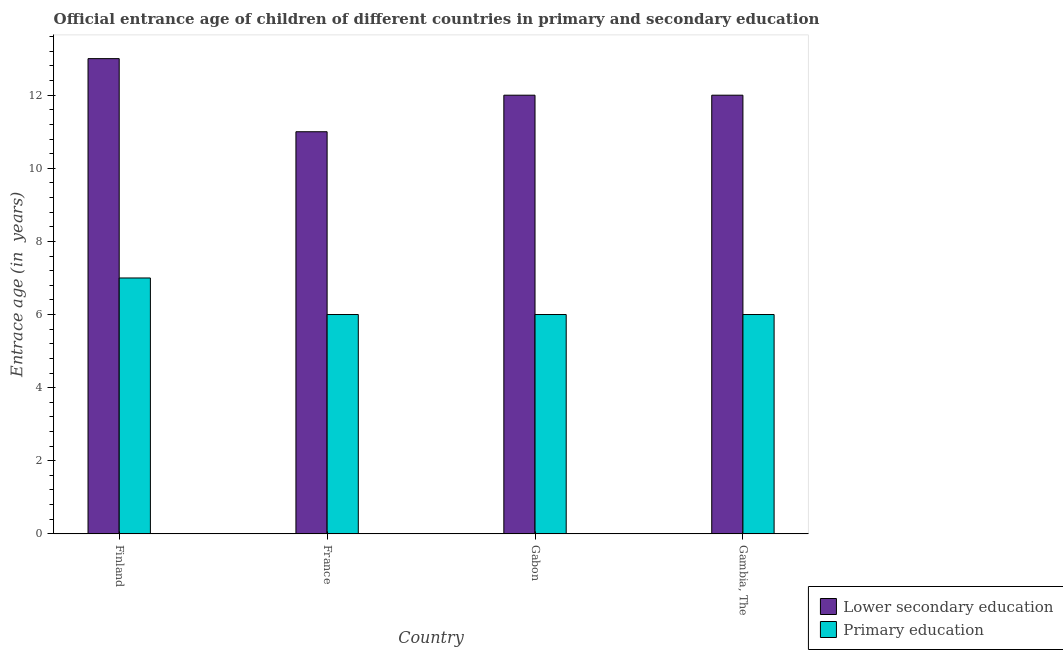Are the number of bars per tick equal to the number of legend labels?
Give a very brief answer. Yes. Are the number of bars on each tick of the X-axis equal?
Offer a very short reply. Yes. How many bars are there on the 2nd tick from the right?
Ensure brevity in your answer.  2. What is the label of the 1st group of bars from the left?
Provide a short and direct response. Finland. In how many cases, is the number of bars for a given country not equal to the number of legend labels?
Make the answer very short. 0. What is the entrance age of children in lower secondary education in Finland?
Keep it short and to the point. 13. Across all countries, what is the maximum entrance age of children in lower secondary education?
Offer a terse response. 13. Across all countries, what is the minimum entrance age of children in lower secondary education?
Keep it short and to the point. 11. In which country was the entrance age of chiildren in primary education maximum?
Ensure brevity in your answer.  Finland. In which country was the entrance age of chiildren in primary education minimum?
Provide a succinct answer. France. What is the total entrance age of children in lower secondary education in the graph?
Provide a succinct answer. 48. What is the difference between the entrance age of chiildren in primary education in Finland and that in Gambia, The?
Keep it short and to the point. 1. What is the average entrance age of chiildren in primary education per country?
Make the answer very short. 6.25. What is the difference between the entrance age of children in lower secondary education and entrance age of chiildren in primary education in Gambia, The?
Keep it short and to the point. 6. What is the ratio of the entrance age of chiildren in primary education in Gabon to that in Gambia, The?
Your answer should be very brief. 1. Is the difference between the entrance age of children in lower secondary education in France and Gabon greater than the difference between the entrance age of chiildren in primary education in France and Gabon?
Ensure brevity in your answer.  No. What is the difference between the highest and the second highest entrance age of chiildren in primary education?
Keep it short and to the point. 1. What is the difference between the highest and the lowest entrance age of chiildren in primary education?
Your answer should be compact. 1. In how many countries, is the entrance age of chiildren in primary education greater than the average entrance age of chiildren in primary education taken over all countries?
Your response must be concise. 1. What does the 2nd bar from the right in France represents?
Provide a short and direct response. Lower secondary education. How many bars are there?
Offer a terse response. 8. Are all the bars in the graph horizontal?
Offer a terse response. No. How many countries are there in the graph?
Your answer should be compact. 4. What is the difference between two consecutive major ticks on the Y-axis?
Ensure brevity in your answer.  2. Does the graph contain any zero values?
Keep it short and to the point. No. Where does the legend appear in the graph?
Keep it short and to the point. Bottom right. How are the legend labels stacked?
Make the answer very short. Vertical. What is the title of the graph?
Your response must be concise. Official entrance age of children of different countries in primary and secondary education. What is the label or title of the Y-axis?
Ensure brevity in your answer.  Entrace age (in  years). What is the Entrace age (in  years) in Lower secondary education in France?
Ensure brevity in your answer.  11. What is the Entrace age (in  years) in Primary education in France?
Ensure brevity in your answer.  6. What is the Entrace age (in  years) of Primary education in Gambia, The?
Offer a terse response. 6. What is the total Entrace age (in  years) in Lower secondary education in the graph?
Provide a succinct answer. 48. What is the difference between the Entrace age (in  years) of Lower secondary education in Finland and that in France?
Give a very brief answer. 2. What is the difference between the Entrace age (in  years) of Primary education in Finland and that in France?
Provide a short and direct response. 1. What is the difference between the Entrace age (in  years) of Lower secondary education in Finland and that in Gabon?
Give a very brief answer. 1. What is the difference between the Entrace age (in  years) of Primary education in Finland and that in Gabon?
Your response must be concise. 1. What is the difference between the Entrace age (in  years) in Lower secondary education in Finland and that in Gambia, The?
Your answer should be compact. 1. What is the difference between the Entrace age (in  years) in Primary education in Finland and that in Gambia, The?
Your answer should be very brief. 1. What is the difference between the Entrace age (in  years) in Lower secondary education in France and that in Gabon?
Keep it short and to the point. -1. What is the difference between the Entrace age (in  years) of Primary education in France and that in Gabon?
Your answer should be very brief. 0. What is the difference between the Entrace age (in  years) in Lower secondary education in France and that in Gambia, The?
Keep it short and to the point. -1. What is the difference between the Entrace age (in  years) in Lower secondary education in Gabon and that in Gambia, The?
Offer a very short reply. 0. What is the difference between the Entrace age (in  years) of Primary education in Gabon and that in Gambia, The?
Provide a short and direct response. 0. What is the difference between the Entrace age (in  years) of Lower secondary education in Finland and the Entrace age (in  years) of Primary education in France?
Offer a terse response. 7. What is the difference between the Entrace age (in  years) of Lower secondary education in Finland and the Entrace age (in  years) of Primary education in Gambia, The?
Your response must be concise. 7. What is the difference between the Entrace age (in  years) of Lower secondary education in France and the Entrace age (in  years) of Primary education in Gabon?
Ensure brevity in your answer.  5. What is the average Entrace age (in  years) in Primary education per country?
Give a very brief answer. 6.25. What is the difference between the Entrace age (in  years) in Lower secondary education and Entrace age (in  years) in Primary education in Finland?
Your answer should be very brief. 6. What is the difference between the Entrace age (in  years) in Lower secondary education and Entrace age (in  years) in Primary education in France?
Your answer should be compact. 5. What is the difference between the Entrace age (in  years) of Lower secondary education and Entrace age (in  years) of Primary education in Gambia, The?
Offer a very short reply. 6. What is the ratio of the Entrace age (in  years) in Lower secondary education in Finland to that in France?
Make the answer very short. 1.18. What is the ratio of the Entrace age (in  years) of Primary education in Finland to that in France?
Your answer should be very brief. 1.17. What is the ratio of the Entrace age (in  years) of Lower secondary education in Finland to that in Gabon?
Provide a short and direct response. 1.08. What is the ratio of the Entrace age (in  years) in Primary education in France to that in Gambia, The?
Make the answer very short. 1. What is the ratio of the Entrace age (in  years) in Lower secondary education in Gabon to that in Gambia, The?
Make the answer very short. 1. What is the difference between the highest and the second highest Entrace age (in  years) of Lower secondary education?
Provide a short and direct response. 1. What is the difference between the highest and the second highest Entrace age (in  years) in Primary education?
Offer a terse response. 1. What is the difference between the highest and the lowest Entrace age (in  years) in Lower secondary education?
Make the answer very short. 2. 